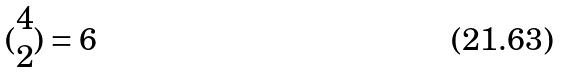Convert formula to latex. <formula><loc_0><loc_0><loc_500><loc_500>( \begin{matrix} 4 \\ 2 \end{matrix} ) = 6</formula> 